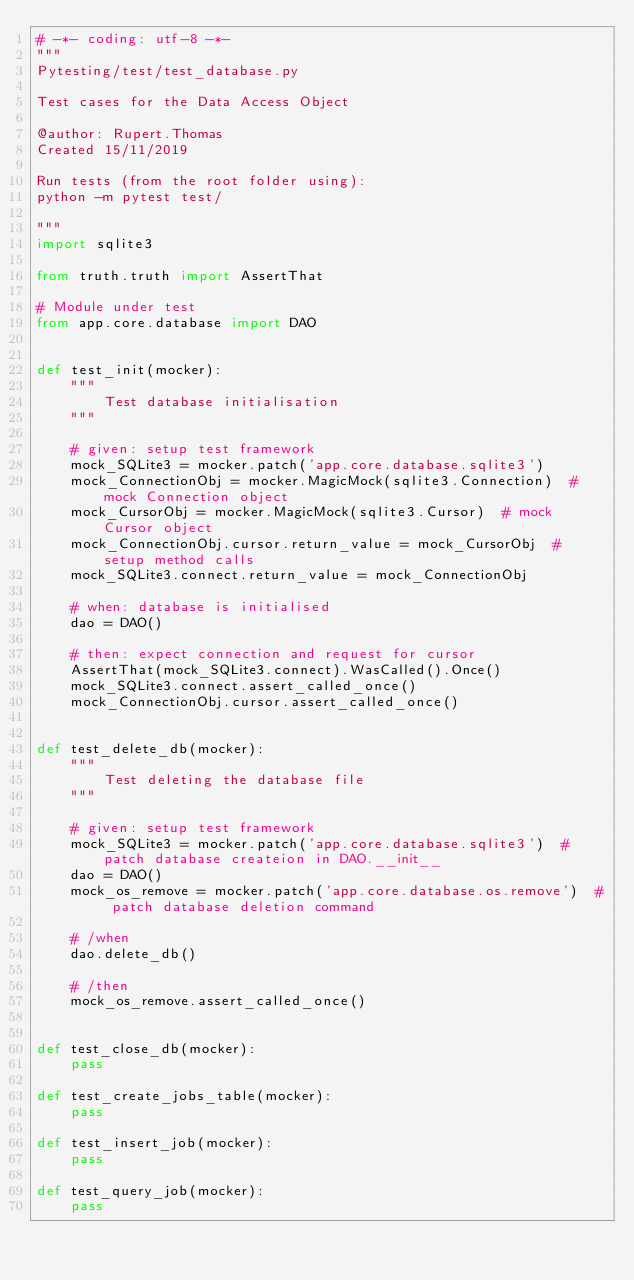Convert code to text. <code><loc_0><loc_0><loc_500><loc_500><_Python_># -*- coding: utf-8 -*-
"""
Pytesting/test/test_database.py

Test cases for the Data Access Object

@author: Rupert.Thomas
Created 15/11/2019

Run tests (from the root folder using):
python -m pytest test/

"""
import sqlite3

from truth.truth import AssertThat

# Module under test
from app.core.database import DAO


def test_init(mocker):
    """
        Test database initialisation
    """

    # given: setup test framework
    mock_SQLite3 = mocker.patch('app.core.database.sqlite3')
    mock_ConnectionObj = mocker.MagicMock(sqlite3.Connection)  # mock Connection object
    mock_CursorObj = mocker.MagicMock(sqlite3.Cursor)  # mock Cursor object
    mock_ConnectionObj.cursor.return_value = mock_CursorObj  # setup method calls
    mock_SQLite3.connect.return_value = mock_ConnectionObj
    
    # when: database is initialised
    dao = DAO()
    
    # then: expect connection and request for cursor
    AssertThat(mock_SQLite3.connect).WasCalled().Once()
    mock_SQLite3.connect.assert_called_once()
    mock_ConnectionObj.cursor.assert_called_once()


def test_delete_db(mocker):
    """
        Test deleting the database file
    """
    
    # given: setup test framework
    mock_SQLite3 = mocker.patch('app.core.database.sqlite3')  # patch database createion in DAO.__init__
    dao = DAO()
    mock_os_remove = mocker.patch('app.core.database.os.remove')  # patch database deletion command

    # /when
    dao.delete_db()
    
    # /then
    mock_os_remove.assert_called_once()


def test_close_db(mocker):
    pass

def test_create_jobs_table(mocker):
    pass

def test_insert_job(mocker):
    pass

def test_query_job(mocker):
    pass
</code> 